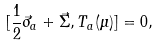Convert formula to latex. <formula><loc_0><loc_0><loc_500><loc_500>[ \frac { 1 } { 2 } \vec { \sigma } _ { a } + \vec { \Sigma } , T _ { a } ( \mu ) ] = 0 ,</formula> 